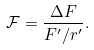<formula> <loc_0><loc_0><loc_500><loc_500>\mathcal { F } = \frac { \Delta F } { F ^ { \prime } / r ^ { \prime } } .</formula> 